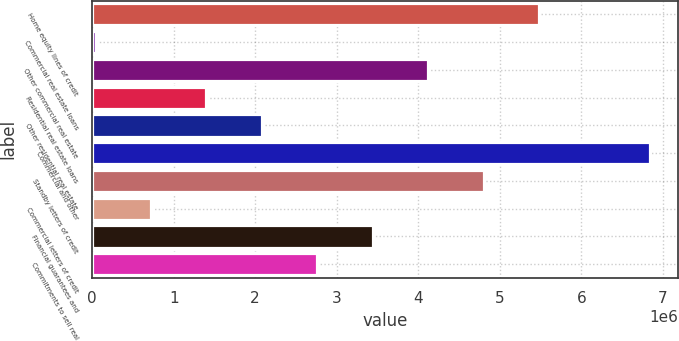Convert chart to OTSL. <chart><loc_0><loc_0><loc_500><loc_500><bar_chart><fcel>Home equity lines of credit<fcel>Commercial real estate loans<fcel>Other commercial real estate<fcel>Residential real estate loans<fcel>Other residential real estate<fcel>Commercial and other<fcel>Standby letters of credit<fcel>Commercial letters of credit<fcel>Financial guarantees and<fcel>Commitments to sell real<nl><fcel>5.48287e+06<fcel>41662<fcel>4.12257e+06<fcel>1.40196e+06<fcel>2.08211e+06<fcel>6.84317e+06<fcel>4.80272e+06<fcel>721813<fcel>3.44242e+06<fcel>2.76227e+06<nl></chart> 